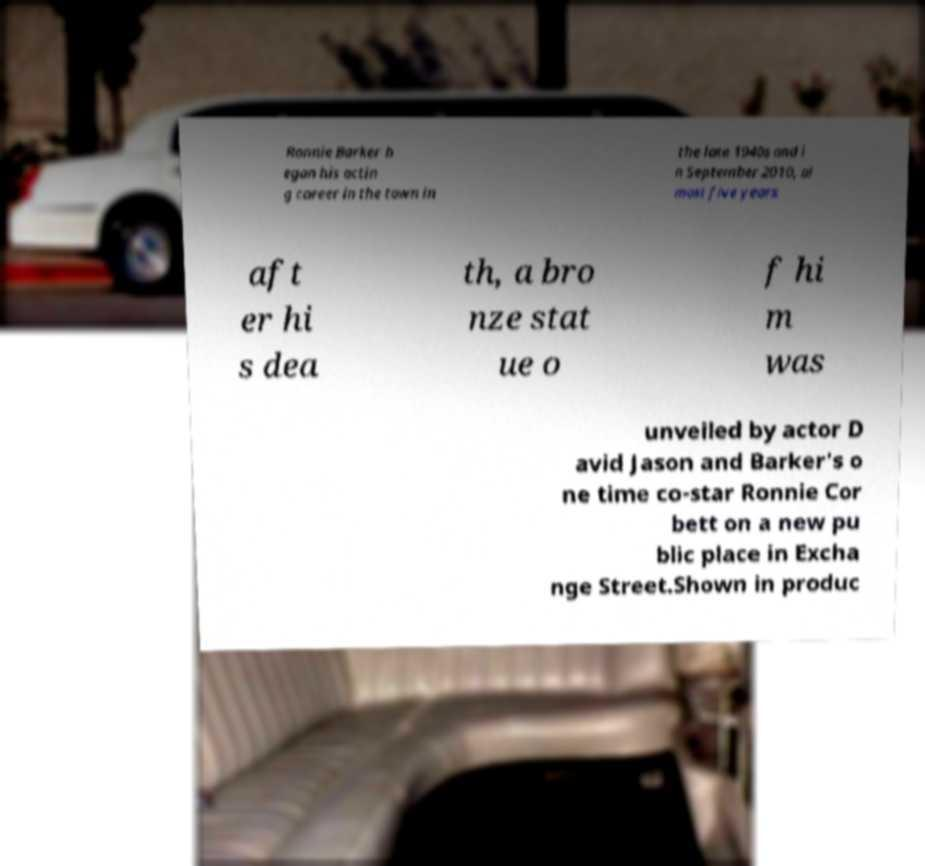Could you assist in decoding the text presented in this image and type it out clearly? Ronnie Barker b egan his actin g career in the town in the late 1940s and i n September 2010, al most five years aft er hi s dea th, a bro nze stat ue o f hi m was unveiled by actor D avid Jason and Barker's o ne time co-star Ronnie Cor bett on a new pu blic place in Excha nge Street.Shown in produc 